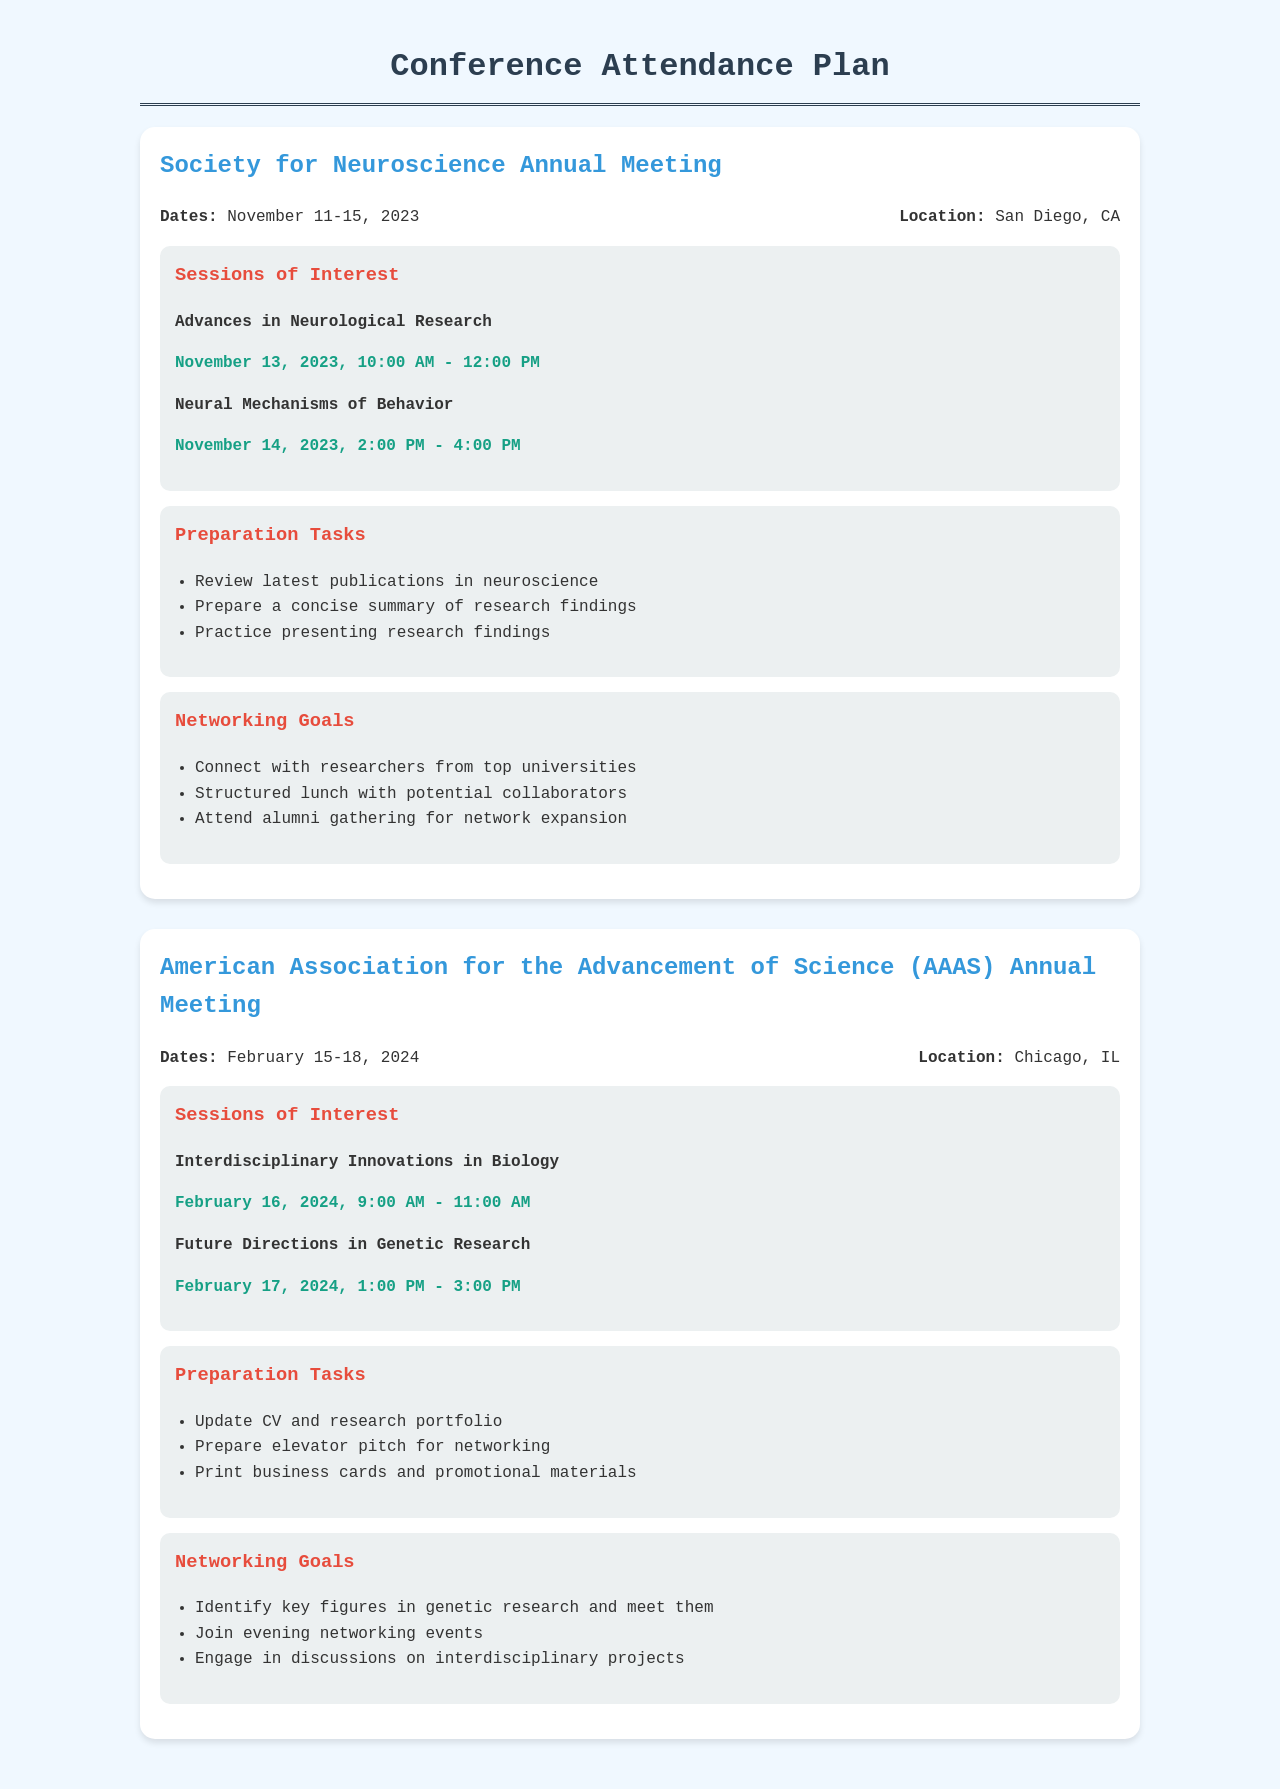What are the dates of the Society for Neuroscience Annual Meeting? The dates can be found in the section describing the conference, listing November 11-15, 2023.
Answer: November 11-15, 2023 Where is the AAAS Annual Meeting located? The location is provided in the details of the AAAS conference, which is Chicago, IL.
Answer: Chicago, IL What session is scheduled on February 16, 2024, at the AAAS Annual Meeting? The document lists "Interdisciplinary Innovations in Biology" as the session on that date.
Answer: Interdisciplinary Innovations in Biology What is one of the preparation tasks for the Society for Neuroscience Annual Meeting? The document includes preparation tasks, one of which is to review latest publications in neuroscience.
Answer: Review latest publications in neuroscience Which session at the Society for Neuroscience Annual Meeting takes place on November 14, 2023? The document mentions "Neural Mechanisms of Behavior" for that date.
Answer: Neural Mechanisms of Behavior What is one networking goal for the AAAS Annual Meeting? The networking goals section identifies multiple targets, one being to identify key figures in genetic research and meet them.
Answer: Identify key figures in genetic research and meet them How many sessions of interest are listed for the Society for Neuroscience Annual Meeting? The document details two sessions of interest under that conference.
Answer: 2 What time is the "Future Directions in Genetic Research" session scheduled? The document provides the session time as February 17, 2024, from 1:00 PM to 3:00 PM.
Answer: 1:00 PM - 3:00 PM What is a preparation task for the AAAS Annual Meeting? In the preparation section, one task highlighted is to prepare an elevator pitch for networking.
Answer: Prepare elevator pitch for networking 